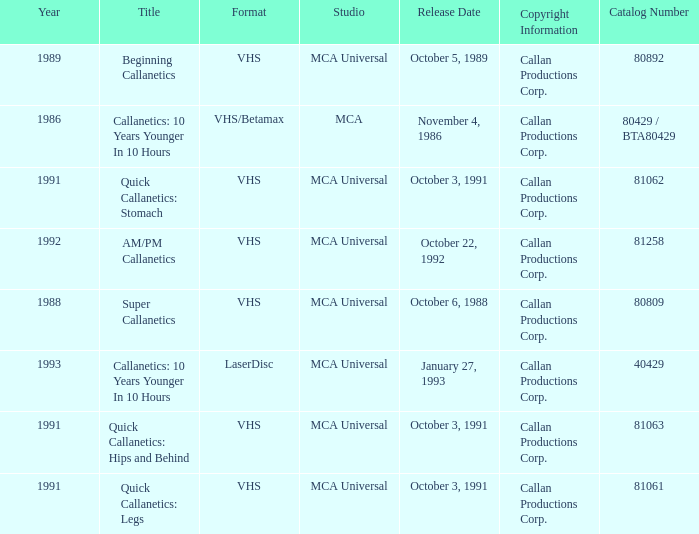Name the studio for super callanetics MCA Universal. 